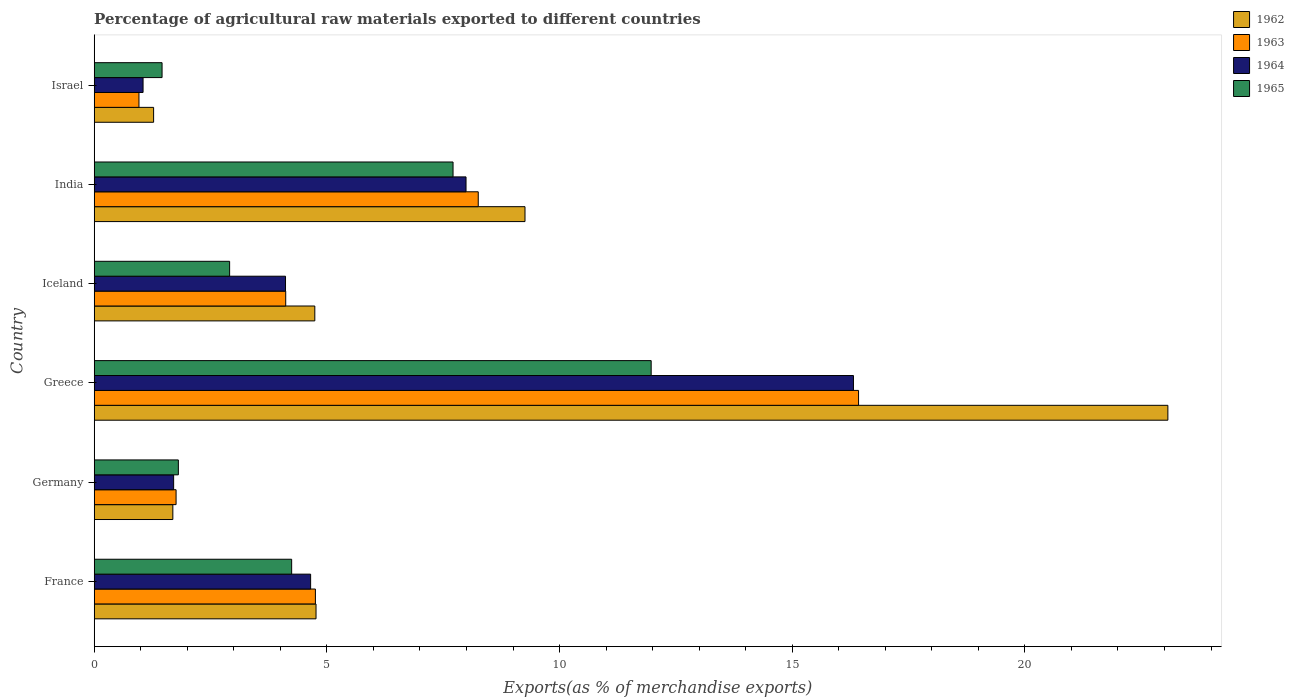How many different coloured bars are there?
Offer a very short reply. 4. How many groups of bars are there?
Offer a terse response. 6. In how many cases, is the number of bars for a given country not equal to the number of legend labels?
Offer a terse response. 0. What is the percentage of exports to different countries in 1963 in Iceland?
Provide a succinct answer. 4.12. Across all countries, what is the maximum percentage of exports to different countries in 1963?
Your answer should be compact. 16.43. Across all countries, what is the minimum percentage of exports to different countries in 1965?
Your answer should be compact. 1.46. In which country was the percentage of exports to different countries in 1963 maximum?
Give a very brief answer. Greece. In which country was the percentage of exports to different countries in 1965 minimum?
Your response must be concise. Israel. What is the total percentage of exports to different countries in 1964 in the graph?
Your answer should be compact. 35.82. What is the difference between the percentage of exports to different countries in 1965 in France and that in Israel?
Keep it short and to the point. 2.78. What is the difference between the percentage of exports to different countries in 1965 in Iceland and the percentage of exports to different countries in 1962 in Germany?
Offer a very short reply. 1.22. What is the average percentage of exports to different countries in 1963 per country?
Keep it short and to the point. 6.04. What is the difference between the percentage of exports to different countries in 1965 and percentage of exports to different countries in 1962 in France?
Keep it short and to the point. -0.52. In how many countries, is the percentage of exports to different countries in 1965 greater than 5 %?
Provide a short and direct response. 2. What is the ratio of the percentage of exports to different countries in 1963 in India to that in Israel?
Provide a succinct answer. 8.58. What is the difference between the highest and the second highest percentage of exports to different countries in 1962?
Provide a succinct answer. 13.81. What is the difference between the highest and the lowest percentage of exports to different countries in 1964?
Provide a short and direct response. 15.27. In how many countries, is the percentage of exports to different countries in 1963 greater than the average percentage of exports to different countries in 1963 taken over all countries?
Offer a terse response. 2. Is the sum of the percentage of exports to different countries in 1962 in Greece and India greater than the maximum percentage of exports to different countries in 1964 across all countries?
Offer a terse response. Yes. What does the 1st bar from the top in Iceland represents?
Keep it short and to the point. 1965. What does the 2nd bar from the bottom in Israel represents?
Provide a short and direct response. 1963. Is it the case that in every country, the sum of the percentage of exports to different countries in 1963 and percentage of exports to different countries in 1965 is greater than the percentage of exports to different countries in 1962?
Ensure brevity in your answer.  Yes. How many bars are there?
Your answer should be very brief. 24. Are all the bars in the graph horizontal?
Provide a short and direct response. Yes. How many countries are there in the graph?
Give a very brief answer. 6. What is the difference between two consecutive major ticks on the X-axis?
Provide a short and direct response. 5. Are the values on the major ticks of X-axis written in scientific E-notation?
Provide a succinct answer. No. What is the title of the graph?
Keep it short and to the point. Percentage of agricultural raw materials exported to different countries. What is the label or title of the X-axis?
Your response must be concise. Exports(as % of merchandise exports). What is the label or title of the Y-axis?
Make the answer very short. Country. What is the Exports(as % of merchandise exports) of 1962 in France?
Your response must be concise. 4.77. What is the Exports(as % of merchandise exports) in 1963 in France?
Ensure brevity in your answer.  4.75. What is the Exports(as % of merchandise exports) in 1964 in France?
Ensure brevity in your answer.  4.65. What is the Exports(as % of merchandise exports) in 1965 in France?
Make the answer very short. 4.24. What is the Exports(as % of merchandise exports) in 1962 in Germany?
Your response must be concise. 1.69. What is the Exports(as % of merchandise exports) of 1963 in Germany?
Provide a short and direct response. 1.76. What is the Exports(as % of merchandise exports) of 1964 in Germany?
Give a very brief answer. 1.71. What is the Exports(as % of merchandise exports) of 1965 in Germany?
Your answer should be compact. 1.81. What is the Exports(as % of merchandise exports) of 1962 in Greece?
Your answer should be compact. 23.07. What is the Exports(as % of merchandise exports) of 1963 in Greece?
Make the answer very short. 16.43. What is the Exports(as % of merchandise exports) in 1964 in Greece?
Ensure brevity in your answer.  16.32. What is the Exports(as % of merchandise exports) in 1965 in Greece?
Provide a short and direct response. 11.97. What is the Exports(as % of merchandise exports) of 1962 in Iceland?
Your answer should be very brief. 4.74. What is the Exports(as % of merchandise exports) of 1963 in Iceland?
Your response must be concise. 4.12. What is the Exports(as % of merchandise exports) of 1964 in Iceland?
Offer a very short reply. 4.11. What is the Exports(as % of merchandise exports) in 1965 in Iceland?
Your answer should be compact. 2.91. What is the Exports(as % of merchandise exports) of 1962 in India?
Offer a very short reply. 9.26. What is the Exports(as % of merchandise exports) of 1963 in India?
Provide a succinct answer. 8.25. What is the Exports(as % of merchandise exports) in 1964 in India?
Keep it short and to the point. 7.99. What is the Exports(as % of merchandise exports) in 1965 in India?
Your response must be concise. 7.71. What is the Exports(as % of merchandise exports) in 1962 in Israel?
Ensure brevity in your answer.  1.28. What is the Exports(as % of merchandise exports) in 1963 in Israel?
Provide a short and direct response. 0.96. What is the Exports(as % of merchandise exports) of 1964 in Israel?
Your answer should be very brief. 1.05. What is the Exports(as % of merchandise exports) of 1965 in Israel?
Offer a very short reply. 1.46. Across all countries, what is the maximum Exports(as % of merchandise exports) in 1962?
Make the answer very short. 23.07. Across all countries, what is the maximum Exports(as % of merchandise exports) of 1963?
Provide a short and direct response. 16.43. Across all countries, what is the maximum Exports(as % of merchandise exports) in 1964?
Your answer should be compact. 16.32. Across all countries, what is the maximum Exports(as % of merchandise exports) of 1965?
Your answer should be very brief. 11.97. Across all countries, what is the minimum Exports(as % of merchandise exports) in 1962?
Offer a terse response. 1.28. Across all countries, what is the minimum Exports(as % of merchandise exports) of 1963?
Ensure brevity in your answer.  0.96. Across all countries, what is the minimum Exports(as % of merchandise exports) of 1964?
Your answer should be very brief. 1.05. Across all countries, what is the minimum Exports(as % of merchandise exports) in 1965?
Give a very brief answer. 1.46. What is the total Exports(as % of merchandise exports) in 1962 in the graph?
Make the answer very short. 44.8. What is the total Exports(as % of merchandise exports) in 1963 in the graph?
Offer a terse response. 36.27. What is the total Exports(as % of merchandise exports) of 1964 in the graph?
Give a very brief answer. 35.83. What is the total Exports(as % of merchandise exports) in 1965 in the graph?
Provide a short and direct response. 30.1. What is the difference between the Exports(as % of merchandise exports) in 1962 in France and that in Germany?
Offer a very short reply. 3.08. What is the difference between the Exports(as % of merchandise exports) of 1963 in France and that in Germany?
Offer a very short reply. 2.99. What is the difference between the Exports(as % of merchandise exports) in 1964 in France and that in Germany?
Your response must be concise. 2.94. What is the difference between the Exports(as % of merchandise exports) in 1965 in France and that in Germany?
Provide a short and direct response. 2.43. What is the difference between the Exports(as % of merchandise exports) of 1962 in France and that in Greece?
Keep it short and to the point. -18.3. What is the difference between the Exports(as % of merchandise exports) in 1963 in France and that in Greece?
Provide a short and direct response. -11.67. What is the difference between the Exports(as % of merchandise exports) in 1964 in France and that in Greece?
Offer a very short reply. -11.66. What is the difference between the Exports(as % of merchandise exports) in 1965 in France and that in Greece?
Your answer should be very brief. -7.73. What is the difference between the Exports(as % of merchandise exports) in 1962 in France and that in Iceland?
Offer a terse response. 0.03. What is the difference between the Exports(as % of merchandise exports) in 1963 in France and that in Iceland?
Make the answer very short. 0.64. What is the difference between the Exports(as % of merchandise exports) in 1964 in France and that in Iceland?
Your response must be concise. 0.54. What is the difference between the Exports(as % of merchandise exports) in 1965 in France and that in Iceland?
Keep it short and to the point. 1.33. What is the difference between the Exports(as % of merchandise exports) of 1962 in France and that in India?
Your answer should be very brief. -4.49. What is the difference between the Exports(as % of merchandise exports) of 1963 in France and that in India?
Give a very brief answer. -3.5. What is the difference between the Exports(as % of merchandise exports) in 1964 in France and that in India?
Provide a short and direct response. -3.34. What is the difference between the Exports(as % of merchandise exports) in 1965 in France and that in India?
Provide a short and direct response. -3.47. What is the difference between the Exports(as % of merchandise exports) in 1962 in France and that in Israel?
Ensure brevity in your answer.  3.49. What is the difference between the Exports(as % of merchandise exports) of 1963 in France and that in Israel?
Offer a terse response. 3.79. What is the difference between the Exports(as % of merchandise exports) in 1964 in France and that in Israel?
Provide a succinct answer. 3.6. What is the difference between the Exports(as % of merchandise exports) of 1965 in France and that in Israel?
Make the answer very short. 2.78. What is the difference between the Exports(as % of merchandise exports) in 1962 in Germany and that in Greece?
Provide a short and direct response. -21.38. What is the difference between the Exports(as % of merchandise exports) of 1963 in Germany and that in Greece?
Your response must be concise. -14.67. What is the difference between the Exports(as % of merchandise exports) of 1964 in Germany and that in Greece?
Keep it short and to the point. -14.61. What is the difference between the Exports(as % of merchandise exports) of 1965 in Germany and that in Greece?
Keep it short and to the point. -10.16. What is the difference between the Exports(as % of merchandise exports) of 1962 in Germany and that in Iceland?
Ensure brevity in your answer.  -3.05. What is the difference between the Exports(as % of merchandise exports) in 1963 in Germany and that in Iceland?
Offer a very short reply. -2.36. What is the difference between the Exports(as % of merchandise exports) of 1964 in Germany and that in Iceland?
Keep it short and to the point. -2.4. What is the difference between the Exports(as % of merchandise exports) of 1965 in Germany and that in Iceland?
Your response must be concise. -1.1. What is the difference between the Exports(as % of merchandise exports) of 1962 in Germany and that in India?
Keep it short and to the point. -7.57. What is the difference between the Exports(as % of merchandise exports) of 1963 in Germany and that in India?
Give a very brief answer. -6.49. What is the difference between the Exports(as % of merchandise exports) in 1964 in Germany and that in India?
Ensure brevity in your answer.  -6.28. What is the difference between the Exports(as % of merchandise exports) of 1965 in Germany and that in India?
Keep it short and to the point. -5.9. What is the difference between the Exports(as % of merchandise exports) in 1962 in Germany and that in Israel?
Your answer should be very brief. 0.41. What is the difference between the Exports(as % of merchandise exports) in 1963 in Germany and that in Israel?
Offer a very short reply. 0.8. What is the difference between the Exports(as % of merchandise exports) in 1964 in Germany and that in Israel?
Your response must be concise. 0.66. What is the difference between the Exports(as % of merchandise exports) in 1965 in Germany and that in Israel?
Offer a terse response. 0.35. What is the difference between the Exports(as % of merchandise exports) in 1962 in Greece and that in Iceland?
Your answer should be compact. 18.33. What is the difference between the Exports(as % of merchandise exports) in 1963 in Greece and that in Iceland?
Provide a short and direct response. 12.31. What is the difference between the Exports(as % of merchandise exports) in 1964 in Greece and that in Iceland?
Provide a succinct answer. 12.2. What is the difference between the Exports(as % of merchandise exports) in 1965 in Greece and that in Iceland?
Your answer should be very brief. 9.06. What is the difference between the Exports(as % of merchandise exports) of 1962 in Greece and that in India?
Provide a short and direct response. 13.81. What is the difference between the Exports(as % of merchandise exports) of 1963 in Greece and that in India?
Offer a terse response. 8.17. What is the difference between the Exports(as % of merchandise exports) of 1964 in Greece and that in India?
Offer a terse response. 8.33. What is the difference between the Exports(as % of merchandise exports) in 1965 in Greece and that in India?
Offer a terse response. 4.26. What is the difference between the Exports(as % of merchandise exports) in 1962 in Greece and that in Israel?
Keep it short and to the point. 21.8. What is the difference between the Exports(as % of merchandise exports) of 1963 in Greece and that in Israel?
Your response must be concise. 15.46. What is the difference between the Exports(as % of merchandise exports) of 1964 in Greece and that in Israel?
Keep it short and to the point. 15.27. What is the difference between the Exports(as % of merchandise exports) in 1965 in Greece and that in Israel?
Offer a terse response. 10.51. What is the difference between the Exports(as % of merchandise exports) of 1962 in Iceland and that in India?
Offer a terse response. -4.52. What is the difference between the Exports(as % of merchandise exports) in 1963 in Iceland and that in India?
Offer a terse response. -4.14. What is the difference between the Exports(as % of merchandise exports) of 1964 in Iceland and that in India?
Give a very brief answer. -3.88. What is the difference between the Exports(as % of merchandise exports) in 1965 in Iceland and that in India?
Your answer should be very brief. -4.8. What is the difference between the Exports(as % of merchandise exports) of 1962 in Iceland and that in Israel?
Offer a terse response. 3.46. What is the difference between the Exports(as % of merchandise exports) in 1963 in Iceland and that in Israel?
Your answer should be compact. 3.15. What is the difference between the Exports(as % of merchandise exports) of 1964 in Iceland and that in Israel?
Ensure brevity in your answer.  3.06. What is the difference between the Exports(as % of merchandise exports) in 1965 in Iceland and that in Israel?
Provide a succinct answer. 1.45. What is the difference between the Exports(as % of merchandise exports) of 1962 in India and that in Israel?
Offer a terse response. 7.98. What is the difference between the Exports(as % of merchandise exports) of 1963 in India and that in Israel?
Offer a very short reply. 7.29. What is the difference between the Exports(as % of merchandise exports) in 1964 in India and that in Israel?
Offer a very short reply. 6.94. What is the difference between the Exports(as % of merchandise exports) in 1965 in India and that in Israel?
Keep it short and to the point. 6.25. What is the difference between the Exports(as % of merchandise exports) in 1962 in France and the Exports(as % of merchandise exports) in 1963 in Germany?
Provide a succinct answer. 3.01. What is the difference between the Exports(as % of merchandise exports) in 1962 in France and the Exports(as % of merchandise exports) in 1964 in Germany?
Your answer should be compact. 3.06. What is the difference between the Exports(as % of merchandise exports) in 1962 in France and the Exports(as % of merchandise exports) in 1965 in Germany?
Your answer should be very brief. 2.96. What is the difference between the Exports(as % of merchandise exports) in 1963 in France and the Exports(as % of merchandise exports) in 1964 in Germany?
Give a very brief answer. 3.05. What is the difference between the Exports(as % of merchandise exports) of 1963 in France and the Exports(as % of merchandise exports) of 1965 in Germany?
Your response must be concise. 2.94. What is the difference between the Exports(as % of merchandise exports) of 1964 in France and the Exports(as % of merchandise exports) of 1965 in Germany?
Provide a succinct answer. 2.84. What is the difference between the Exports(as % of merchandise exports) of 1962 in France and the Exports(as % of merchandise exports) of 1963 in Greece?
Offer a very short reply. -11.66. What is the difference between the Exports(as % of merchandise exports) in 1962 in France and the Exports(as % of merchandise exports) in 1964 in Greece?
Your response must be concise. -11.55. What is the difference between the Exports(as % of merchandise exports) in 1962 in France and the Exports(as % of merchandise exports) in 1965 in Greece?
Make the answer very short. -7.2. What is the difference between the Exports(as % of merchandise exports) of 1963 in France and the Exports(as % of merchandise exports) of 1964 in Greece?
Your answer should be very brief. -11.56. What is the difference between the Exports(as % of merchandise exports) in 1963 in France and the Exports(as % of merchandise exports) in 1965 in Greece?
Make the answer very short. -7.22. What is the difference between the Exports(as % of merchandise exports) in 1964 in France and the Exports(as % of merchandise exports) in 1965 in Greece?
Make the answer very short. -7.32. What is the difference between the Exports(as % of merchandise exports) in 1962 in France and the Exports(as % of merchandise exports) in 1963 in Iceland?
Give a very brief answer. 0.65. What is the difference between the Exports(as % of merchandise exports) of 1962 in France and the Exports(as % of merchandise exports) of 1964 in Iceland?
Give a very brief answer. 0.66. What is the difference between the Exports(as % of merchandise exports) of 1962 in France and the Exports(as % of merchandise exports) of 1965 in Iceland?
Ensure brevity in your answer.  1.86. What is the difference between the Exports(as % of merchandise exports) in 1963 in France and the Exports(as % of merchandise exports) in 1964 in Iceland?
Your response must be concise. 0.64. What is the difference between the Exports(as % of merchandise exports) of 1963 in France and the Exports(as % of merchandise exports) of 1965 in Iceland?
Give a very brief answer. 1.84. What is the difference between the Exports(as % of merchandise exports) of 1964 in France and the Exports(as % of merchandise exports) of 1965 in Iceland?
Keep it short and to the point. 1.74. What is the difference between the Exports(as % of merchandise exports) of 1962 in France and the Exports(as % of merchandise exports) of 1963 in India?
Keep it short and to the point. -3.49. What is the difference between the Exports(as % of merchandise exports) in 1962 in France and the Exports(as % of merchandise exports) in 1964 in India?
Make the answer very short. -3.22. What is the difference between the Exports(as % of merchandise exports) of 1962 in France and the Exports(as % of merchandise exports) of 1965 in India?
Offer a very short reply. -2.94. What is the difference between the Exports(as % of merchandise exports) in 1963 in France and the Exports(as % of merchandise exports) in 1964 in India?
Offer a very short reply. -3.24. What is the difference between the Exports(as % of merchandise exports) of 1963 in France and the Exports(as % of merchandise exports) of 1965 in India?
Your response must be concise. -2.96. What is the difference between the Exports(as % of merchandise exports) in 1964 in France and the Exports(as % of merchandise exports) in 1965 in India?
Provide a short and direct response. -3.06. What is the difference between the Exports(as % of merchandise exports) in 1962 in France and the Exports(as % of merchandise exports) in 1963 in Israel?
Make the answer very short. 3.8. What is the difference between the Exports(as % of merchandise exports) of 1962 in France and the Exports(as % of merchandise exports) of 1964 in Israel?
Your response must be concise. 3.72. What is the difference between the Exports(as % of merchandise exports) in 1962 in France and the Exports(as % of merchandise exports) in 1965 in Israel?
Provide a succinct answer. 3.31. What is the difference between the Exports(as % of merchandise exports) of 1963 in France and the Exports(as % of merchandise exports) of 1964 in Israel?
Your answer should be very brief. 3.7. What is the difference between the Exports(as % of merchandise exports) in 1963 in France and the Exports(as % of merchandise exports) in 1965 in Israel?
Offer a very short reply. 3.3. What is the difference between the Exports(as % of merchandise exports) of 1964 in France and the Exports(as % of merchandise exports) of 1965 in Israel?
Your response must be concise. 3.19. What is the difference between the Exports(as % of merchandise exports) of 1962 in Germany and the Exports(as % of merchandise exports) of 1963 in Greece?
Offer a terse response. -14.74. What is the difference between the Exports(as % of merchandise exports) of 1962 in Germany and the Exports(as % of merchandise exports) of 1964 in Greece?
Provide a short and direct response. -14.63. What is the difference between the Exports(as % of merchandise exports) in 1962 in Germany and the Exports(as % of merchandise exports) in 1965 in Greece?
Provide a succinct answer. -10.28. What is the difference between the Exports(as % of merchandise exports) of 1963 in Germany and the Exports(as % of merchandise exports) of 1964 in Greece?
Give a very brief answer. -14.56. What is the difference between the Exports(as % of merchandise exports) in 1963 in Germany and the Exports(as % of merchandise exports) in 1965 in Greece?
Provide a short and direct response. -10.21. What is the difference between the Exports(as % of merchandise exports) in 1964 in Germany and the Exports(as % of merchandise exports) in 1965 in Greece?
Make the answer very short. -10.26. What is the difference between the Exports(as % of merchandise exports) of 1962 in Germany and the Exports(as % of merchandise exports) of 1963 in Iceland?
Your answer should be very brief. -2.43. What is the difference between the Exports(as % of merchandise exports) in 1962 in Germany and the Exports(as % of merchandise exports) in 1964 in Iceland?
Offer a very short reply. -2.42. What is the difference between the Exports(as % of merchandise exports) in 1962 in Germany and the Exports(as % of merchandise exports) in 1965 in Iceland?
Offer a terse response. -1.22. What is the difference between the Exports(as % of merchandise exports) of 1963 in Germany and the Exports(as % of merchandise exports) of 1964 in Iceland?
Your answer should be very brief. -2.35. What is the difference between the Exports(as % of merchandise exports) of 1963 in Germany and the Exports(as % of merchandise exports) of 1965 in Iceland?
Your answer should be compact. -1.15. What is the difference between the Exports(as % of merchandise exports) in 1964 in Germany and the Exports(as % of merchandise exports) in 1965 in Iceland?
Your answer should be very brief. -1.2. What is the difference between the Exports(as % of merchandise exports) in 1962 in Germany and the Exports(as % of merchandise exports) in 1963 in India?
Give a very brief answer. -6.56. What is the difference between the Exports(as % of merchandise exports) in 1962 in Germany and the Exports(as % of merchandise exports) in 1964 in India?
Ensure brevity in your answer.  -6.3. What is the difference between the Exports(as % of merchandise exports) of 1962 in Germany and the Exports(as % of merchandise exports) of 1965 in India?
Your response must be concise. -6.02. What is the difference between the Exports(as % of merchandise exports) of 1963 in Germany and the Exports(as % of merchandise exports) of 1964 in India?
Provide a short and direct response. -6.23. What is the difference between the Exports(as % of merchandise exports) of 1963 in Germany and the Exports(as % of merchandise exports) of 1965 in India?
Offer a terse response. -5.95. What is the difference between the Exports(as % of merchandise exports) in 1964 in Germany and the Exports(as % of merchandise exports) in 1965 in India?
Your answer should be compact. -6. What is the difference between the Exports(as % of merchandise exports) of 1962 in Germany and the Exports(as % of merchandise exports) of 1963 in Israel?
Ensure brevity in your answer.  0.73. What is the difference between the Exports(as % of merchandise exports) in 1962 in Germany and the Exports(as % of merchandise exports) in 1964 in Israel?
Keep it short and to the point. 0.64. What is the difference between the Exports(as % of merchandise exports) of 1962 in Germany and the Exports(as % of merchandise exports) of 1965 in Israel?
Make the answer very short. 0.23. What is the difference between the Exports(as % of merchandise exports) of 1963 in Germany and the Exports(as % of merchandise exports) of 1964 in Israel?
Provide a succinct answer. 0.71. What is the difference between the Exports(as % of merchandise exports) in 1963 in Germany and the Exports(as % of merchandise exports) in 1965 in Israel?
Your answer should be compact. 0.3. What is the difference between the Exports(as % of merchandise exports) of 1964 in Germany and the Exports(as % of merchandise exports) of 1965 in Israel?
Keep it short and to the point. 0.25. What is the difference between the Exports(as % of merchandise exports) of 1962 in Greece and the Exports(as % of merchandise exports) of 1963 in Iceland?
Give a very brief answer. 18.96. What is the difference between the Exports(as % of merchandise exports) of 1962 in Greece and the Exports(as % of merchandise exports) of 1964 in Iceland?
Your answer should be very brief. 18.96. What is the difference between the Exports(as % of merchandise exports) in 1962 in Greece and the Exports(as % of merchandise exports) in 1965 in Iceland?
Provide a succinct answer. 20.16. What is the difference between the Exports(as % of merchandise exports) in 1963 in Greece and the Exports(as % of merchandise exports) in 1964 in Iceland?
Offer a very short reply. 12.31. What is the difference between the Exports(as % of merchandise exports) in 1963 in Greece and the Exports(as % of merchandise exports) in 1965 in Iceland?
Offer a very short reply. 13.52. What is the difference between the Exports(as % of merchandise exports) of 1964 in Greece and the Exports(as % of merchandise exports) of 1965 in Iceland?
Keep it short and to the point. 13.41. What is the difference between the Exports(as % of merchandise exports) in 1962 in Greece and the Exports(as % of merchandise exports) in 1963 in India?
Give a very brief answer. 14.82. What is the difference between the Exports(as % of merchandise exports) in 1962 in Greece and the Exports(as % of merchandise exports) in 1964 in India?
Give a very brief answer. 15.08. What is the difference between the Exports(as % of merchandise exports) of 1962 in Greece and the Exports(as % of merchandise exports) of 1965 in India?
Offer a very short reply. 15.36. What is the difference between the Exports(as % of merchandise exports) in 1963 in Greece and the Exports(as % of merchandise exports) in 1964 in India?
Offer a terse response. 8.44. What is the difference between the Exports(as % of merchandise exports) of 1963 in Greece and the Exports(as % of merchandise exports) of 1965 in India?
Your response must be concise. 8.71. What is the difference between the Exports(as % of merchandise exports) of 1964 in Greece and the Exports(as % of merchandise exports) of 1965 in India?
Your answer should be compact. 8.6. What is the difference between the Exports(as % of merchandise exports) of 1962 in Greece and the Exports(as % of merchandise exports) of 1963 in Israel?
Ensure brevity in your answer.  22.11. What is the difference between the Exports(as % of merchandise exports) of 1962 in Greece and the Exports(as % of merchandise exports) of 1964 in Israel?
Your answer should be very brief. 22.02. What is the difference between the Exports(as % of merchandise exports) in 1962 in Greece and the Exports(as % of merchandise exports) in 1965 in Israel?
Your answer should be compact. 21.61. What is the difference between the Exports(as % of merchandise exports) in 1963 in Greece and the Exports(as % of merchandise exports) in 1964 in Israel?
Your response must be concise. 15.38. What is the difference between the Exports(as % of merchandise exports) of 1963 in Greece and the Exports(as % of merchandise exports) of 1965 in Israel?
Your response must be concise. 14.97. What is the difference between the Exports(as % of merchandise exports) in 1964 in Greece and the Exports(as % of merchandise exports) in 1965 in Israel?
Ensure brevity in your answer.  14.86. What is the difference between the Exports(as % of merchandise exports) of 1962 in Iceland and the Exports(as % of merchandise exports) of 1963 in India?
Offer a terse response. -3.51. What is the difference between the Exports(as % of merchandise exports) of 1962 in Iceland and the Exports(as % of merchandise exports) of 1964 in India?
Your answer should be compact. -3.25. What is the difference between the Exports(as % of merchandise exports) of 1962 in Iceland and the Exports(as % of merchandise exports) of 1965 in India?
Ensure brevity in your answer.  -2.97. What is the difference between the Exports(as % of merchandise exports) of 1963 in Iceland and the Exports(as % of merchandise exports) of 1964 in India?
Offer a terse response. -3.87. What is the difference between the Exports(as % of merchandise exports) of 1963 in Iceland and the Exports(as % of merchandise exports) of 1965 in India?
Your answer should be compact. -3.6. What is the difference between the Exports(as % of merchandise exports) of 1964 in Iceland and the Exports(as % of merchandise exports) of 1965 in India?
Your answer should be very brief. -3.6. What is the difference between the Exports(as % of merchandise exports) in 1962 in Iceland and the Exports(as % of merchandise exports) in 1963 in Israel?
Your answer should be very brief. 3.78. What is the difference between the Exports(as % of merchandise exports) in 1962 in Iceland and the Exports(as % of merchandise exports) in 1964 in Israel?
Your answer should be compact. 3.69. What is the difference between the Exports(as % of merchandise exports) in 1962 in Iceland and the Exports(as % of merchandise exports) in 1965 in Israel?
Your response must be concise. 3.28. What is the difference between the Exports(as % of merchandise exports) in 1963 in Iceland and the Exports(as % of merchandise exports) in 1964 in Israel?
Your answer should be very brief. 3.07. What is the difference between the Exports(as % of merchandise exports) of 1963 in Iceland and the Exports(as % of merchandise exports) of 1965 in Israel?
Make the answer very short. 2.66. What is the difference between the Exports(as % of merchandise exports) of 1964 in Iceland and the Exports(as % of merchandise exports) of 1965 in Israel?
Your answer should be compact. 2.65. What is the difference between the Exports(as % of merchandise exports) of 1962 in India and the Exports(as % of merchandise exports) of 1963 in Israel?
Make the answer very short. 8.3. What is the difference between the Exports(as % of merchandise exports) in 1962 in India and the Exports(as % of merchandise exports) in 1964 in Israel?
Give a very brief answer. 8.21. What is the difference between the Exports(as % of merchandise exports) in 1962 in India and the Exports(as % of merchandise exports) in 1965 in Israel?
Offer a very short reply. 7.8. What is the difference between the Exports(as % of merchandise exports) of 1963 in India and the Exports(as % of merchandise exports) of 1964 in Israel?
Offer a very short reply. 7.2. What is the difference between the Exports(as % of merchandise exports) of 1963 in India and the Exports(as % of merchandise exports) of 1965 in Israel?
Make the answer very short. 6.79. What is the difference between the Exports(as % of merchandise exports) of 1964 in India and the Exports(as % of merchandise exports) of 1965 in Israel?
Keep it short and to the point. 6.53. What is the average Exports(as % of merchandise exports) of 1962 per country?
Provide a succinct answer. 7.47. What is the average Exports(as % of merchandise exports) in 1963 per country?
Your response must be concise. 6.04. What is the average Exports(as % of merchandise exports) in 1964 per country?
Provide a succinct answer. 5.97. What is the average Exports(as % of merchandise exports) in 1965 per country?
Your response must be concise. 5.02. What is the difference between the Exports(as % of merchandise exports) in 1962 and Exports(as % of merchandise exports) in 1963 in France?
Your response must be concise. 0.01. What is the difference between the Exports(as % of merchandise exports) of 1962 and Exports(as % of merchandise exports) of 1964 in France?
Your answer should be very brief. 0.12. What is the difference between the Exports(as % of merchandise exports) in 1962 and Exports(as % of merchandise exports) in 1965 in France?
Ensure brevity in your answer.  0.52. What is the difference between the Exports(as % of merchandise exports) of 1963 and Exports(as % of merchandise exports) of 1964 in France?
Offer a terse response. 0.1. What is the difference between the Exports(as % of merchandise exports) of 1963 and Exports(as % of merchandise exports) of 1965 in France?
Provide a short and direct response. 0.51. What is the difference between the Exports(as % of merchandise exports) in 1964 and Exports(as % of merchandise exports) in 1965 in France?
Your answer should be very brief. 0.41. What is the difference between the Exports(as % of merchandise exports) in 1962 and Exports(as % of merchandise exports) in 1963 in Germany?
Ensure brevity in your answer.  -0.07. What is the difference between the Exports(as % of merchandise exports) in 1962 and Exports(as % of merchandise exports) in 1964 in Germany?
Ensure brevity in your answer.  -0.02. What is the difference between the Exports(as % of merchandise exports) in 1962 and Exports(as % of merchandise exports) in 1965 in Germany?
Your answer should be very brief. -0.12. What is the difference between the Exports(as % of merchandise exports) in 1963 and Exports(as % of merchandise exports) in 1964 in Germany?
Offer a terse response. 0.05. What is the difference between the Exports(as % of merchandise exports) in 1963 and Exports(as % of merchandise exports) in 1965 in Germany?
Ensure brevity in your answer.  -0.05. What is the difference between the Exports(as % of merchandise exports) in 1964 and Exports(as % of merchandise exports) in 1965 in Germany?
Ensure brevity in your answer.  -0.1. What is the difference between the Exports(as % of merchandise exports) in 1962 and Exports(as % of merchandise exports) in 1963 in Greece?
Provide a succinct answer. 6.65. What is the difference between the Exports(as % of merchandise exports) of 1962 and Exports(as % of merchandise exports) of 1964 in Greece?
Ensure brevity in your answer.  6.76. What is the difference between the Exports(as % of merchandise exports) in 1962 and Exports(as % of merchandise exports) in 1965 in Greece?
Provide a short and direct response. 11.1. What is the difference between the Exports(as % of merchandise exports) in 1963 and Exports(as % of merchandise exports) in 1964 in Greece?
Offer a very short reply. 0.11. What is the difference between the Exports(as % of merchandise exports) of 1963 and Exports(as % of merchandise exports) of 1965 in Greece?
Provide a short and direct response. 4.46. What is the difference between the Exports(as % of merchandise exports) in 1964 and Exports(as % of merchandise exports) in 1965 in Greece?
Make the answer very short. 4.35. What is the difference between the Exports(as % of merchandise exports) of 1962 and Exports(as % of merchandise exports) of 1963 in Iceland?
Give a very brief answer. 0.63. What is the difference between the Exports(as % of merchandise exports) of 1962 and Exports(as % of merchandise exports) of 1964 in Iceland?
Keep it short and to the point. 0.63. What is the difference between the Exports(as % of merchandise exports) of 1962 and Exports(as % of merchandise exports) of 1965 in Iceland?
Keep it short and to the point. 1.83. What is the difference between the Exports(as % of merchandise exports) of 1963 and Exports(as % of merchandise exports) of 1964 in Iceland?
Provide a succinct answer. 0. What is the difference between the Exports(as % of merchandise exports) of 1963 and Exports(as % of merchandise exports) of 1965 in Iceland?
Your response must be concise. 1.21. What is the difference between the Exports(as % of merchandise exports) of 1964 and Exports(as % of merchandise exports) of 1965 in Iceland?
Provide a succinct answer. 1.2. What is the difference between the Exports(as % of merchandise exports) of 1962 and Exports(as % of merchandise exports) of 1963 in India?
Keep it short and to the point. 1. What is the difference between the Exports(as % of merchandise exports) in 1962 and Exports(as % of merchandise exports) in 1964 in India?
Offer a terse response. 1.27. What is the difference between the Exports(as % of merchandise exports) of 1962 and Exports(as % of merchandise exports) of 1965 in India?
Provide a succinct answer. 1.55. What is the difference between the Exports(as % of merchandise exports) of 1963 and Exports(as % of merchandise exports) of 1964 in India?
Provide a succinct answer. 0.26. What is the difference between the Exports(as % of merchandise exports) of 1963 and Exports(as % of merchandise exports) of 1965 in India?
Your answer should be very brief. 0.54. What is the difference between the Exports(as % of merchandise exports) in 1964 and Exports(as % of merchandise exports) in 1965 in India?
Keep it short and to the point. 0.28. What is the difference between the Exports(as % of merchandise exports) of 1962 and Exports(as % of merchandise exports) of 1963 in Israel?
Provide a succinct answer. 0.31. What is the difference between the Exports(as % of merchandise exports) of 1962 and Exports(as % of merchandise exports) of 1964 in Israel?
Ensure brevity in your answer.  0.23. What is the difference between the Exports(as % of merchandise exports) in 1962 and Exports(as % of merchandise exports) in 1965 in Israel?
Ensure brevity in your answer.  -0.18. What is the difference between the Exports(as % of merchandise exports) of 1963 and Exports(as % of merchandise exports) of 1964 in Israel?
Provide a succinct answer. -0.09. What is the difference between the Exports(as % of merchandise exports) in 1963 and Exports(as % of merchandise exports) in 1965 in Israel?
Offer a terse response. -0.5. What is the difference between the Exports(as % of merchandise exports) in 1964 and Exports(as % of merchandise exports) in 1965 in Israel?
Provide a short and direct response. -0.41. What is the ratio of the Exports(as % of merchandise exports) of 1962 in France to that in Germany?
Make the answer very short. 2.82. What is the ratio of the Exports(as % of merchandise exports) of 1963 in France to that in Germany?
Give a very brief answer. 2.7. What is the ratio of the Exports(as % of merchandise exports) of 1964 in France to that in Germany?
Keep it short and to the point. 2.72. What is the ratio of the Exports(as % of merchandise exports) of 1965 in France to that in Germany?
Make the answer very short. 2.35. What is the ratio of the Exports(as % of merchandise exports) of 1962 in France to that in Greece?
Your response must be concise. 0.21. What is the ratio of the Exports(as % of merchandise exports) of 1963 in France to that in Greece?
Ensure brevity in your answer.  0.29. What is the ratio of the Exports(as % of merchandise exports) in 1964 in France to that in Greece?
Offer a very short reply. 0.29. What is the ratio of the Exports(as % of merchandise exports) of 1965 in France to that in Greece?
Offer a terse response. 0.35. What is the ratio of the Exports(as % of merchandise exports) of 1962 in France to that in Iceland?
Offer a terse response. 1.01. What is the ratio of the Exports(as % of merchandise exports) of 1963 in France to that in Iceland?
Ensure brevity in your answer.  1.16. What is the ratio of the Exports(as % of merchandise exports) of 1964 in France to that in Iceland?
Offer a terse response. 1.13. What is the ratio of the Exports(as % of merchandise exports) of 1965 in France to that in Iceland?
Provide a short and direct response. 1.46. What is the ratio of the Exports(as % of merchandise exports) in 1962 in France to that in India?
Your answer should be very brief. 0.51. What is the ratio of the Exports(as % of merchandise exports) in 1963 in France to that in India?
Offer a terse response. 0.58. What is the ratio of the Exports(as % of merchandise exports) of 1964 in France to that in India?
Keep it short and to the point. 0.58. What is the ratio of the Exports(as % of merchandise exports) in 1965 in France to that in India?
Provide a succinct answer. 0.55. What is the ratio of the Exports(as % of merchandise exports) of 1962 in France to that in Israel?
Provide a succinct answer. 3.73. What is the ratio of the Exports(as % of merchandise exports) in 1963 in France to that in Israel?
Your answer should be compact. 4.94. What is the ratio of the Exports(as % of merchandise exports) of 1964 in France to that in Israel?
Offer a terse response. 4.43. What is the ratio of the Exports(as % of merchandise exports) of 1965 in France to that in Israel?
Provide a succinct answer. 2.91. What is the ratio of the Exports(as % of merchandise exports) in 1962 in Germany to that in Greece?
Offer a terse response. 0.07. What is the ratio of the Exports(as % of merchandise exports) in 1963 in Germany to that in Greece?
Offer a very short reply. 0.11. What is the ratio of the Exports(as % of merchandise exports) of 1964 in Germany to that in Greece?
Your answer should be very brief. 0.1. What is the ratio of the Exports(as % of merchandise exports) of 1965 in Germany to that in Greece?
Offer a terse response. 0.15. What is the ratio of the Exports(as % of merchandise exports) in 1962 in Germany to that in Iceland?
Ensure brevity in your answer.  0.36. What is the ratio of the Exports(as % of merchandise exports) in 1963 in Germany to that in Iceland?
Make the answer very short. 0.43. What is the ratio of the Exports(as % of merchandise exports) in 1964 in Germany to that in Iceland?
Provide a short and direct response. 0.42. What is the ratio of the Exports(as % of merchandise exports) of 1965 in Germany to that in Iceland?
Offer a terse response. 0.62. What is the ratio of the Exports(as % of merchandise exports) of 1962 in Germany to that in India?
Give a very brief answer. 0.18. What is the ratio of the Exports(as % of merchandise exports) of 1963 in Germany to that in India?
Offer a very short reply. 0.21. What is the ratio of the Exports(as % of merchandise exports) in 1964 in Germany to that in India?
Make the answer very short. 0.21. What is the ratio of the Exports(as % of merchandise exports) in 1965 in Germany to that in India?
Offer a very short reply. 0.23. What is the ratio of the Exports(as % of merchandise exports) in 1962 in Germany to that in Israel?
Provide a succinct answer. 1.32. What is the ratio of the Exports(as % of merchandise exports) of 1963 in Germany to that in Israel?
Offer a terse response. 1.83. What is the ratio of the Exports(as % of merchandise exports) of 1964 in Germany to that in Israel?
Ensure brevity in your answer.  1.63. What is the ratio of the Exports(as % of merchandise exports) in 1965 in Germany to that in Israel?
Give a very brief answer. 1.24. What is the ratio of the Exports(as % of merchandise exports) in 1962 in Greece to that in Iceland?
Give a very brief answer. 4.87. What is the ratio of the Exports(as % of merchandise exports) of 1963 in Greece to that in Iceland?
Offer a terse response. 3.99. What is the ratio of the Exports(as % of merchandise exports) of 1964 in Greece to that in Iceland?
Provide a succinct answer. 3.97. What is the ratio of the Exports(as % of merchandise exports) of 1965 in Greece to that in Iceland?
Offer a terse response. 4.11. What is the ratio of the Exports(as % of merchandise exports) in 1962 in Greece to that in India?
Offer a terse response. 2.49. What is the ratio of the Exports(as % of merchandise exports) in 1963 in Greece to that in India?
Make the answer very short. 1.99. What is the ratio of the Exports(as % of merchandise exports) in 1964 in Greece to that in India?
Offer a very short reply. 2.04. What is the ratio of the Exports(as % of merchandise exports) in 1965 in Greece to that in India?
Ensure brevity in your answer.  1.55. What is the ratio of the Exports(as % of merchandise exports) in 1962 in Greece to that in Israel?
Keep it short and to the point. 18.07. What is the ratio of the Exports(as % of merchandise exports) in 1963 in Greece to that in Israel?
Keep it short and to the point. 17.07. What is the ratio of the Exports(as % of merchandise exports) of 1964 in Greece to that in Israel?
Make the answer very short. 15.54. What is the ratio of the Exports(as % of merchandise exports) in 1965 in Greece to that in Israel?
Offer a terse response. 8.21. What is the ratio of the Exports(as % of merchandise exports) in 1962 in Iceland to that in India?
Keep it short and to the point. 0.51. What is the ratio of the Exports(as % of merchandise exports) in 1963 in Iceland to that in India?
Offer a very short reply. 0.5. What is the ratio of the Exports(as % of merchandise exports) of 1964 in Iceland to that in India?
Keep it short and to the point. 0.51. What is the ratio of the Exports(as % of merchandise exports) of 1965 in Iceland to that in India?
Your answer should be very brief. 0.38. What is the ratio of the Exports(as % of merchandise exports) of 1962 in Iceland to that in Israel?
Offer a terse response. 3.71. What is the ratio of the Exports(as % of merchandise exports) in 1963 in Iceland to that in Israel?
Give a very brief answer. 4.28. What is the ratio of the Exports(as % of merchandise exports) in 1964 in Iceland to that in Israel?
Ensure brevity in your answer.  3.92. What is the ratio of the Exports(as % of merchandise exports) of 1965 in Iceland to that in Israel?
Make the answer very short. 2. What is the ratio of the Exports(as % of merchandise exports) of 1962 in India to that in Israel?
Your answer should be compact. 7.25. What is the ratio of the Exports(as % of merchandise exports) of 1963 in India to that in Israel?
Keep it short and to the point. 8.58. What is the ratio of the Exports(as % of merchandise exports) in 1964 in India to that in Israel?
Provide a short and direct response. 7.61. What is the ratio of the Exports(as % of merchandise exports) in 1965 in India to that in Israel?
Provide a short and direct response. 5.29. What is the difference between the highest and the second highest Exports(as % of merchandise exports) in 1962?
Offer a terse response. 13.81. What is the difference between the highest and the second highest Exports(as % of merchandise exports) of 1963?
Offer a very short reply. 8.17. What is the difference between the highest and the second highest Exports(as % of merchandise exports) in 1964?
Offer a terse response. 8.33. What is the difference between the highest and the second highest Exports(as % of merchandise exports) in 1965?
Make the answer very short. 4.26. What is the difference between the highest and the lowest Exports(as % of merchandise exports) of 1962?
Provide a short and direct response. 21.8. What is the difference between the highest and the lowest Exports(as % of merchandise exports) of 1963?
Provide a short and direct response. 15.46. What is the difference between the highest and the lowest Exports(as % of merchandise exports) in 1964?
Your answer should be compact. 15.27. What is the difference between the highest and the lowest Exports(as % of merchandise exports) of 1965?
Keep it short and to the point. 10.51. 